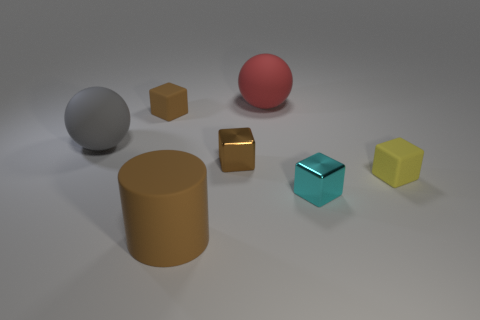Is the shape of the rubber thing to the right of the big red sphere the same as  the large brown rubber object?
Your response must be concise. No. There is a matte thing that is the same color as the cylinder; what size is it?
Provide a short and direct response. Small. Is there a metal object of the same size as the brown metal cube?
Ensure brevity in your answer.  Yes. Is there a metallic thing that is on the right side of the brown cube in front of the matte cube behind the small yellow rubber cube?
Keep it short and to the point. Yes. There is a cylinder; does it have the same color as the matte block that is to the right of the brown matte block?
Make the answer very short. No. What material is the ball on the left side of the tiny brown object that is in front of the rubber block that is on the left side of the small cyan metal object made of?
Your response must be concise. Rubber. The tiny matte thing that is right of the tiny cyan block has what shape?
Keep it short and to the point. Cube. There is a red object that is made of the same material as the large gray thing; what size is it?
Ensure brevity in your answer.  Large. What number of cyan things have the same shape as the red matte object?
Your response must be concise. 0. Does the metallic object that is in front of the tiny yellow object have the same color as the rubber cylinder?
Provide a short and direct response. No. 